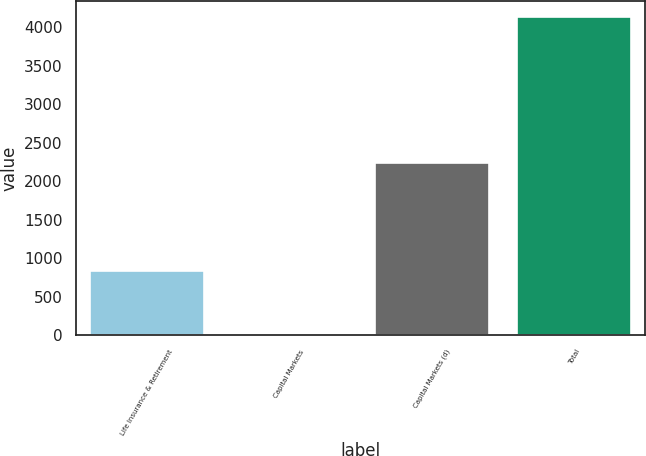<chart> <loc_0><loc_0><loc_500><loc_500><bar_chart><fcel>Life Insurance & Retirement<fcel>Capital Markets<fcel>Capital Markets (d)<fcel>Total<nl><fcel>832.8<fcel>8<fcel>2241<fcel>4132<nl></chart> 